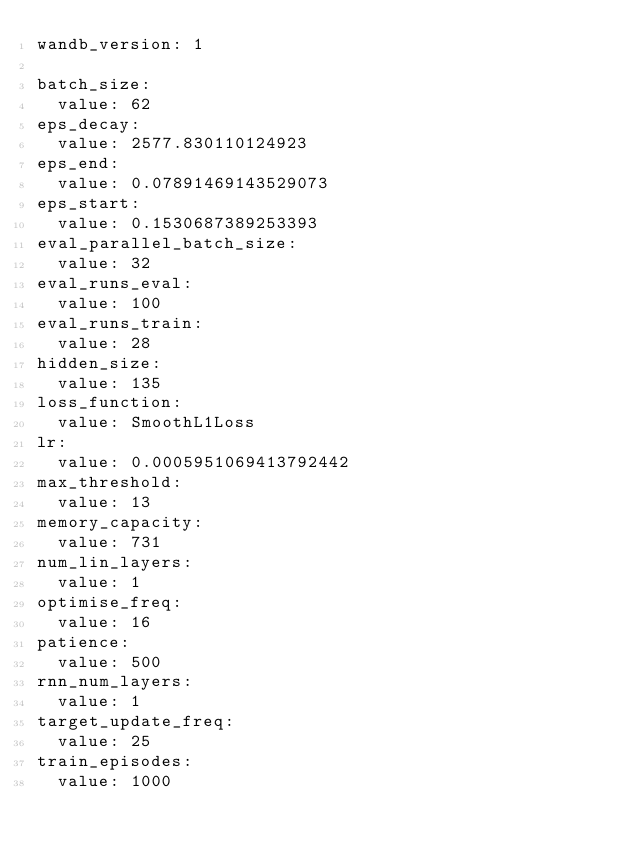<code> <loc_0><loc_0><loc_500><loc_500><_YAML_>wandb_version: 1

batch_size:
  value: 62
eps_decay:
  value: 2577.830110124923
eps_end:
  value: 0.07891469143529073
eps_start:
  value: 0.1530687389253393
eval_parallel_batch_size:
  value: 32
eval_runs_eval:
  value: 100
eval_runs_train:
  value: 28
hidden_size:
  value: 135
loss_function:
  value: SmoothL1Loss
lr:
  value: 0.0005951069413792442
max_threshold:
  value: 13
memory_capacity:
  value: 731
num_lin_layers:
  value: 1
optimise_freq:
  value: 16
patience:
  value: 500
rnn_num_layers:
  value: 1
target_update_freq:
  value: 25
train_episodes:
  value: 1000
</code> 